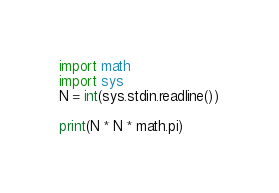<code> <loc_0><loc_0><loc_500><loc_500><_Python_>import math
import sys
N = int(sys.stdin.readline())

print(N * N * math.pi)</code> 